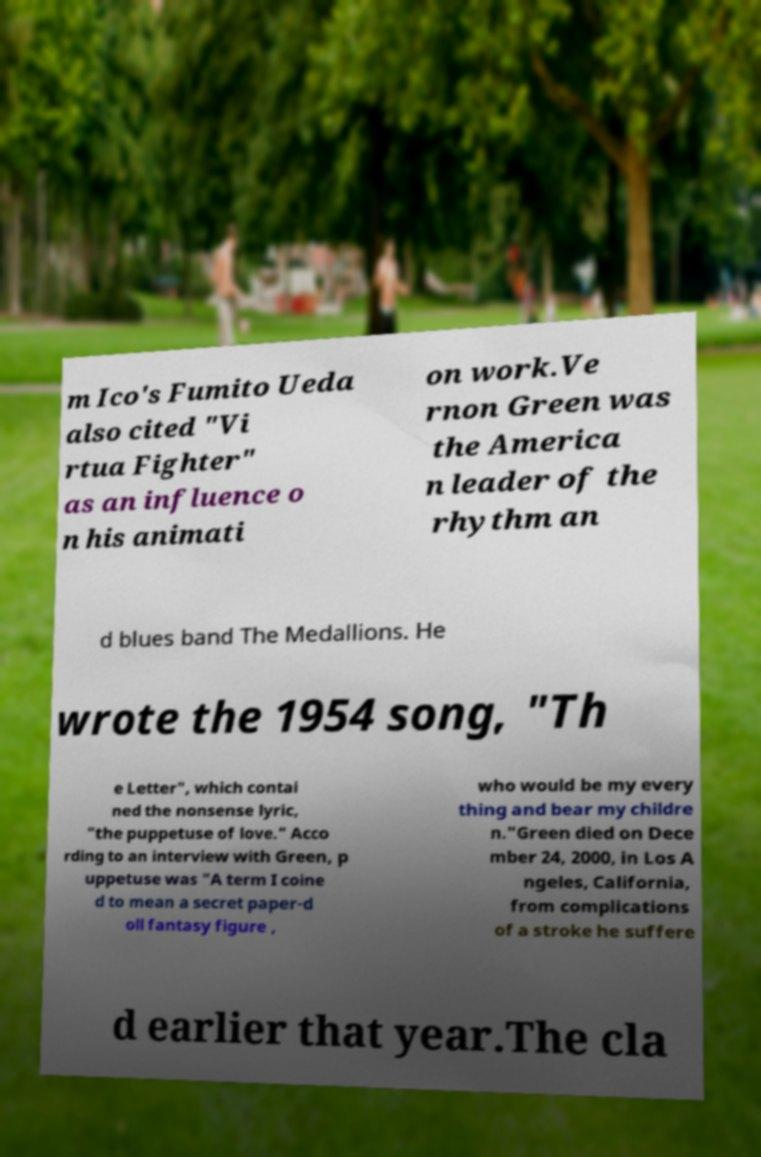What messages or text are displayed in this image? I need them in a readable, typed format. m Ico's Fumito Ueda also cited "Vi rtua Fighter" as an influence o n his animati on work.Ve rnon Green was the America n leader of the rhythm an d blues band The Medallions. He wrote the 1954 song, "Th e Letter", which contai ned the nonsense lyric, "the puppetuse of love." Acco rding to an interview with Green, p uppetuse was "A term I coine d to mean a secret paper-d oll fantasy figure , who would be my every thing and bear my childre n."Green died on Dece mber 24, 2000, in Los A ngeles, California, from complications of a stroke he suffere d earlier that year.The cla 